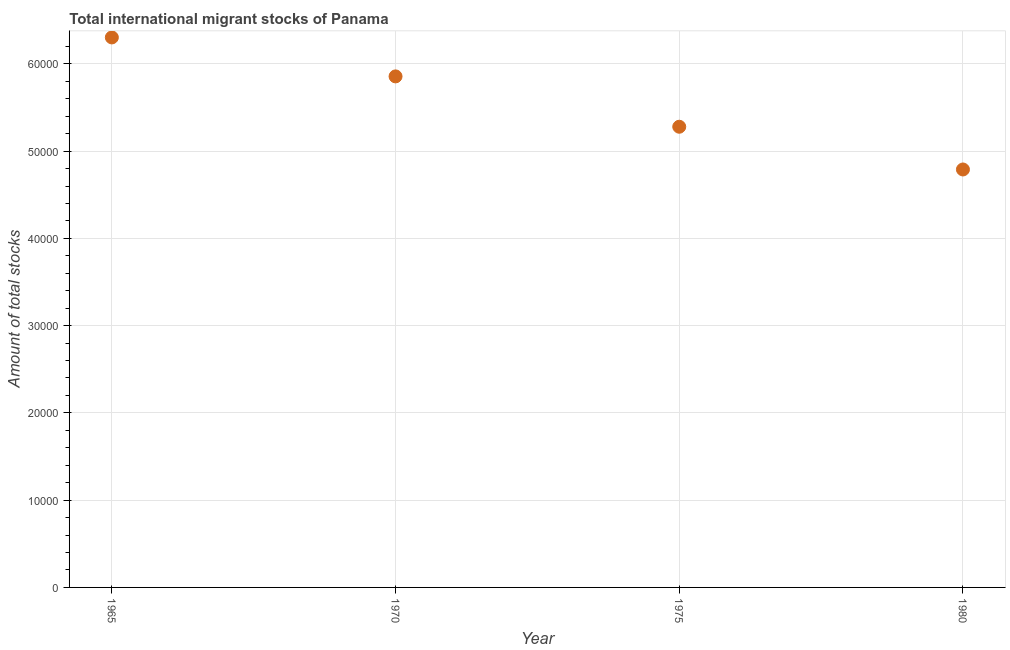What is the total number of international migrant stock in 1965?
Give a very brief answer. 6.30e+04. Across all years, what is the maximum total number of international migrant stock?
Make the answer very short. 6.30e+04. Across all years, what is the minimum total number of international migrant stock?
Make the answer very short. 4.79e+04. In which year was the total number of international migrant stock maximum?
Your answer should be very brief. 1965. What is the sum of the total number of international migrant stock?
Ensure brevity in your answer.  2.22e+05. What is the difference between the total number of international migrant stock in 1965 and 1980?
Provide a succinct answer. 1.51e+04. What is the average total number of international migrant stock per year?
Your answer should be very brief. 5.56e+04. What is the median total number of international migrant stock?
Offer a terse response. 5.57e+04. In how many years, is the total number of international migrant stock greater than 50000 ?
Offer a terse response. 3. What is the ratio of the total number of international migrant stock in 1975 to that in 1980?
Provide a short and direct response. 1.1. What is the difference between the highest and the second highest total number of international migrant stock?
Offer a very short reply. 4465. What is the difference between the highest and the lowest total number of international migrant stock?
Ensure brevity in your answer.  1.51e+04. In how many years, is the total number of international migrant stock greater than the average total number of international migrant stock taken over all years?
Make the answer very short. 2. How many dotlines are there?
Your answer should be very brief. 1. Are the values on the major ticks of Y-axis written in scientific E-notation?
Give a very brief answer. No. Does the graph contain any zero values?
Provide a succinct answer. No. What is the title of the graph?
Keep it short and to the point. Total international migrant stocks of Panama. What is the label or title of the X-axis?
Give a very brief answer. Year. What is the label or title of the Y-axis?
Your response must be concise. Amount of total stocks. What is the Amount of total stocks in 1965?
Offer a terse response. 6.30e+04. What is the Amount of total stocks in 1970?
Give a very brief answer. 5.86e+04. What is the Amount of total stocks in 1975?
Keep it short and to the point. 5.28e+04. What is the Amount of total stocks in 1980?
Your answer should be very brief. 4.79e+04. What is the difference between the Amount of total stocks in 1965 and 1970?
Make the answer very short. 4465. What is the difference between the Amount of total stocks in 1965 and 1975?
Offer a very short reply. 1.02e+04. What is the difference between the Amount of total stocks in 1965 and 1980?
Provide a succinct answer. 1.51e+04. What is the difference between the Amount of total stocks in 1970 and 1975?
Keep it short and to the point. 5770. What is the difference between the Amount of total stocks in 1970 and 1980?
Ensure brevity in your answer.  1.07e+04. What is the difference between the Amount of total stocks in 1975 and 1980?
Your answer should be very brief. 4897. What is the ratio of the Amount of total stocks in 1965 to that in 1970?
Your answer should be compact. 1.08. What is the ratio of the Amount of total stocks in 1965 to that in 1975?
Your answer should be very brief. 1.19. What is the ratio of the Amount of total stocks in 1965 to that in 1980?
Offer a terse response. 1.32. What is the ratio of the Amount of total stocks in 1970 to that in 1975?
Keep it short and to the point. 1.11. What is the ratio of the Amount of total stocks in 1970 to that in 1980?
Offer a terse response. 1.22. What is the ratio of the Amount of total stocks in 1975 to that in 1980?
Make the answer very short. 1.1. 